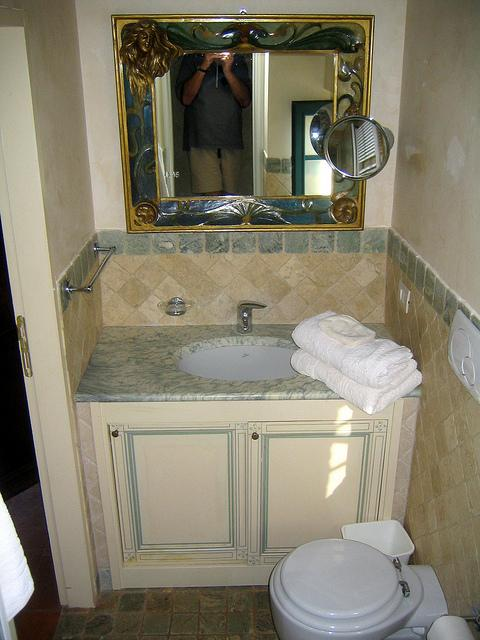What type of mirror is the small circular one referred to as? Please explain your reasoning. make-up. The small mirror is used for makeup application. 